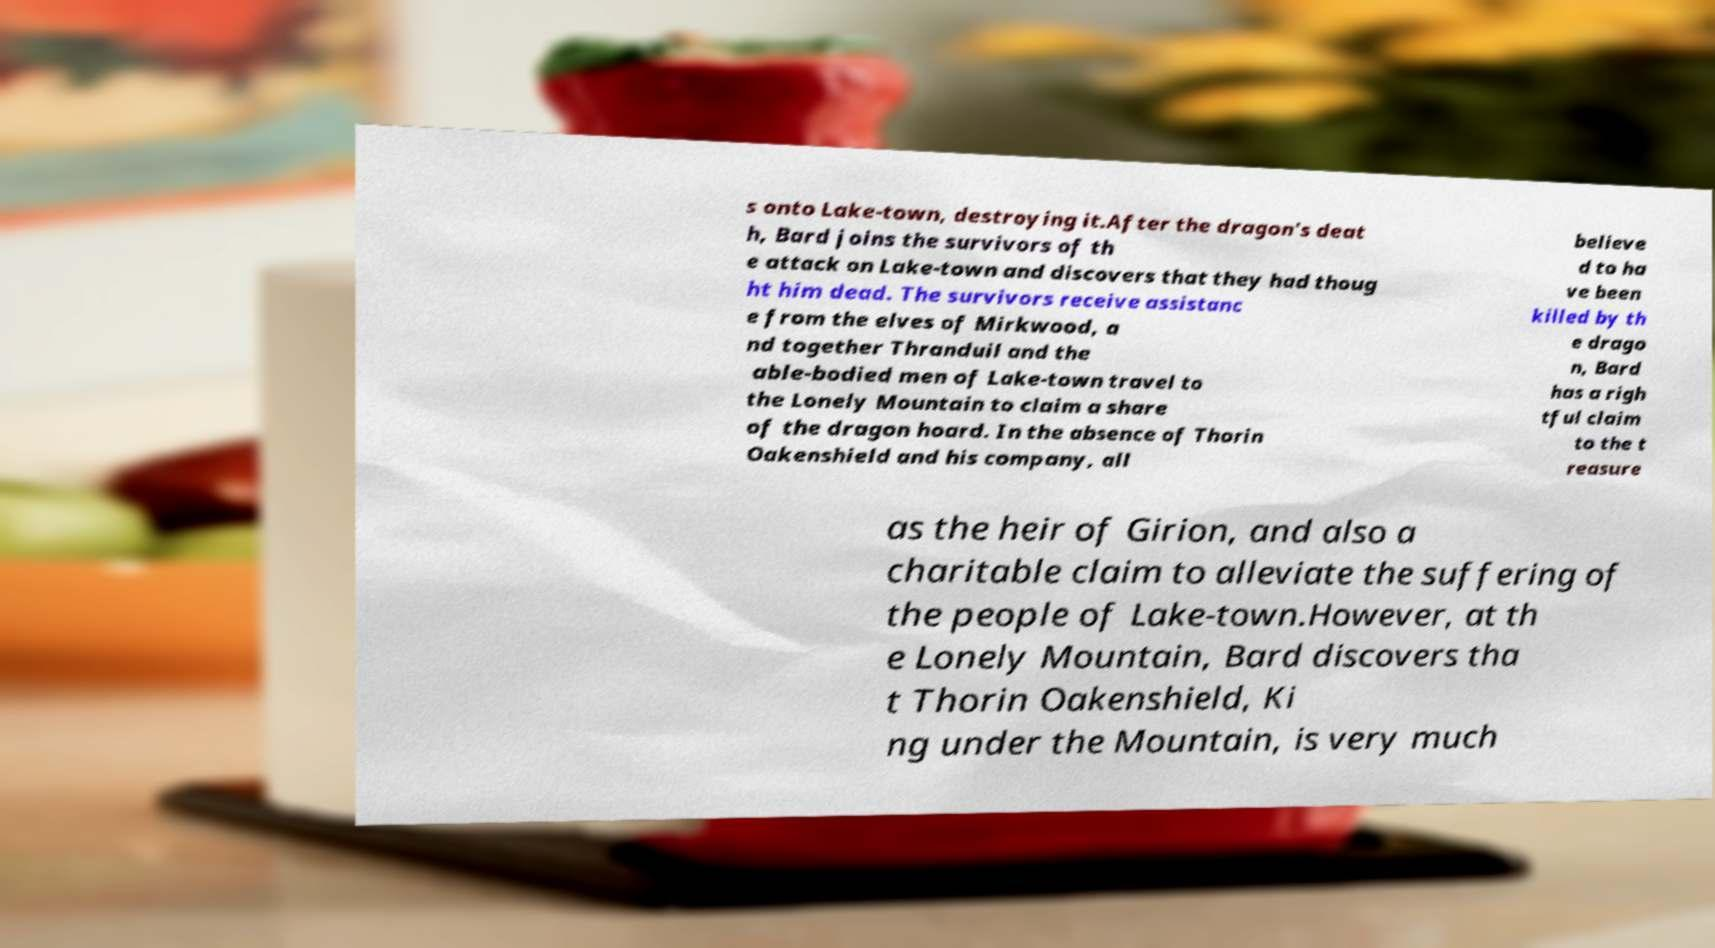There's text embedded in this image that I need extracted. Can you transcribe it verbatim? s onto Lake-town, destroying it.After the dragon's deat h, Bard joins the survivors of th e attack on Lake-town and discovers that they had thoug ht him dead. The survivors receive assistanc e from the elves of Mirkwood, a nd together Thranduil and the able-bodied men of Lake-town travel to the Lonely Mountain to claim a share of the dragon hoard. In the absence of Thorin Oakenshield and his company, all believe d to ha ve been killed by th e drago n, Bard has a righ tful claim to the t reasure as the heir of Girion, and also a charitable claim to alleviate the suffering of the people of Lake-town.However, at th e Lonely Mountain, Bard discovers tha t Thorin Oakenshield, Ki ng under the Mountain, is very much 